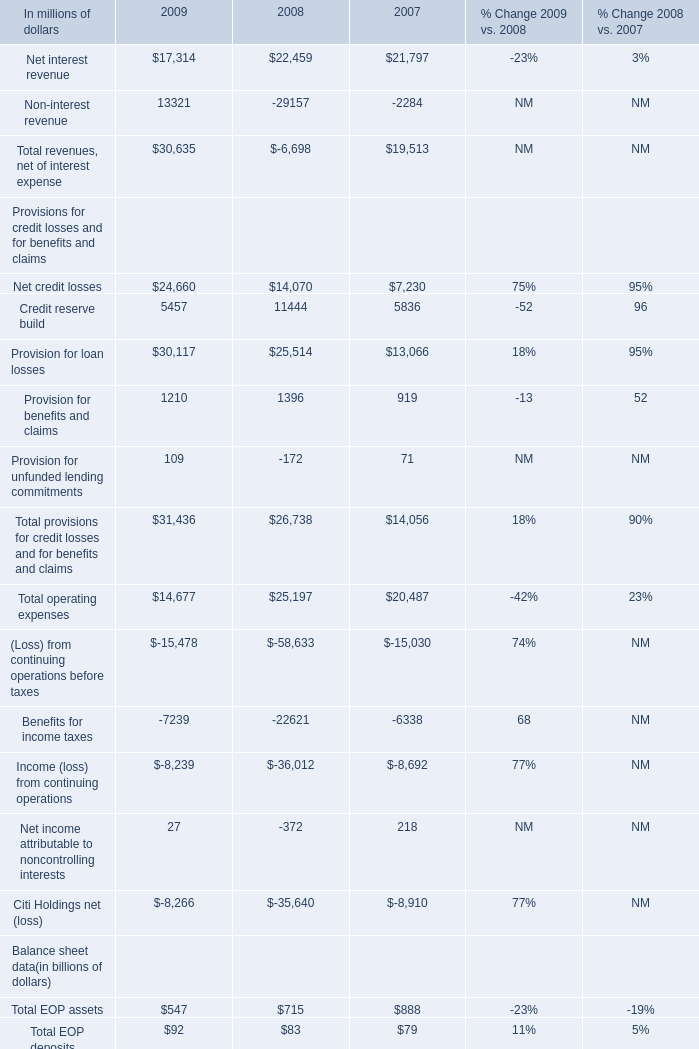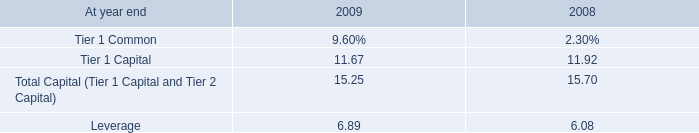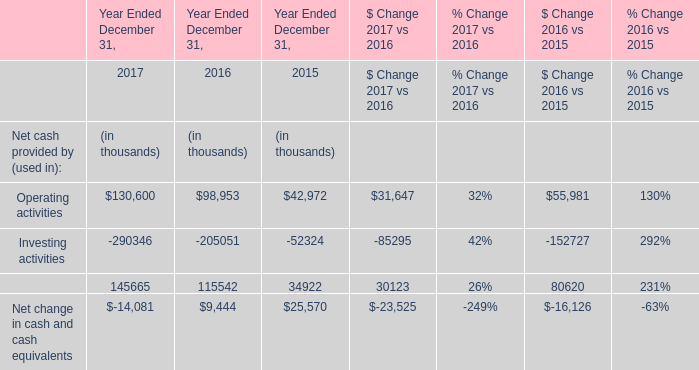What is the total value of Net interest revenue, Non-interest revenue, Total revenues, net of interest expense and Net credit losses in2009? (in million) 
Computations: (((17314 + 13321) + 30635) + 24660)
Answer: 85930.0. 